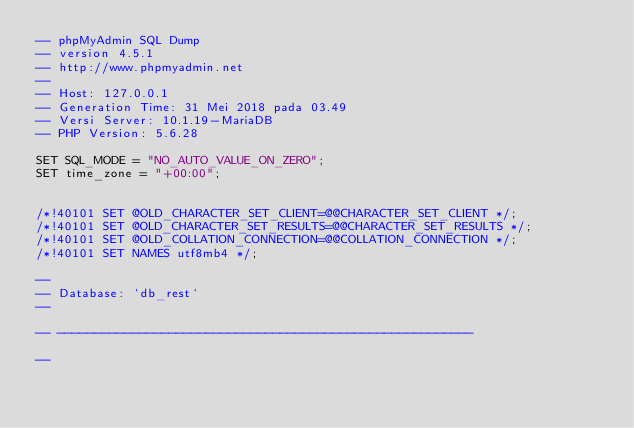<code> <loc_0><loc_0><loc_500><loc_500><_SQL_>-- phpMyAdmin SQL Dump
-- version 4.5.1
-- http://www.phpmyadmin.net
--
-- Host: 127.0.0.1
-- Generation Time: 31 Mei 2018 pada 03.49
-- Versi Server: 10.1.19-MariaDB
-- PHP Version: 5.6.28

SET SQL_MODE = "NO_AUTO_VALUE_ON_ZERO";
SET time_zone = "+00:00";


/*!40101 SET @OLD_CHARACTER_SET_CLIENT=@@CHARACTER_SET_CLIENT */;
/*!40101 SET @OLD_CHARACTER_SET_RESULTS=@@CHARACTER_SET_RESULTS */;
/*!40101 SET @OLD_COLLATION_CONNECTION=@@COLLATION_CONNECTION */;
/*!40101 SET NAMES utf8mb4 */;

--
-- Database: `db_rest`
--

-- --------------------------------------------------------

--</code> 